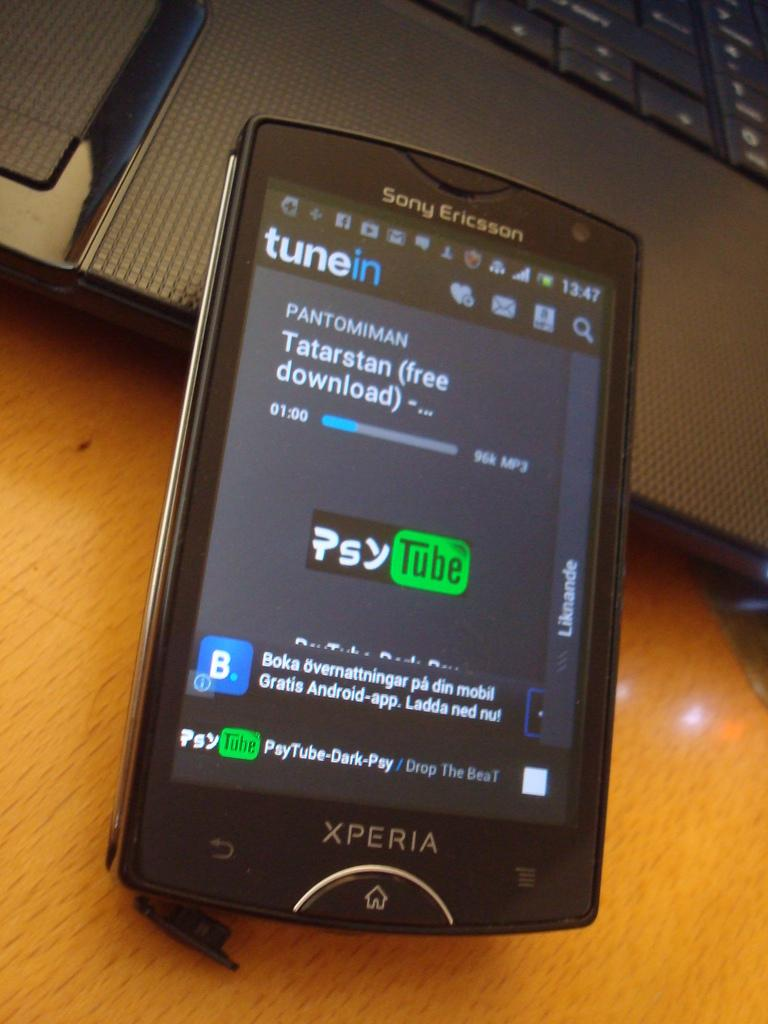<image>
Give a short and clear explanation of the subsequent image. a Sony Ericsson cell phone is powered on 